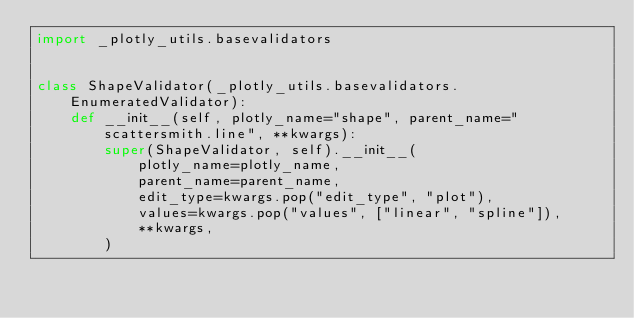<code> <loc_0><loc_0><loc_500><loc_500><_Python_>import _plotly_utils.basevalidators


class ShapeValidator(_plotly_utils.basevalidators.EnumeratedValidator):
    def __init__(self, plotly_name="shape", parent_name="scattersmith.line", **kwargs):
        super(ShapeValidator, self).__init__(
            plotly_name=plotly_name,
            parent_name=parent_name,
            edit_type=kwargs.pop("edit_type", "plot"),
            values=kwargs.pop("values", ["linear", "spline"]),
            **kwargs,
        )
</code> 